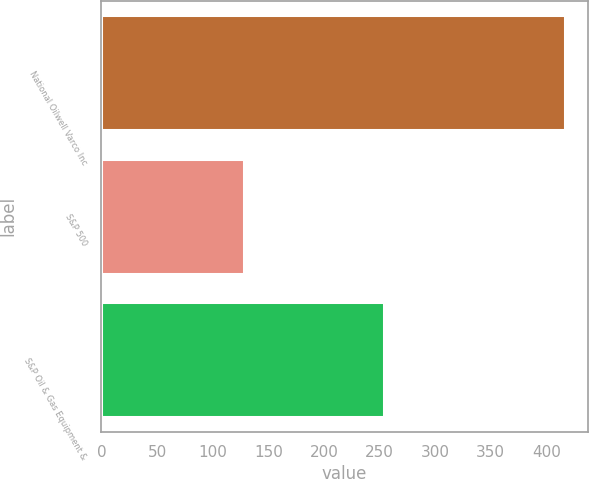Convert chart. <chart><loc_0><loc_0><loc_500><loc_500><bar_chart><fcel>National Oilwell Varco Inc<fcel>S&P 500<fcel>S&P Oil & Gas Equipment &<nl><fcel>416.32<fcel>128.16<fcel>253.87<nl></chart> 